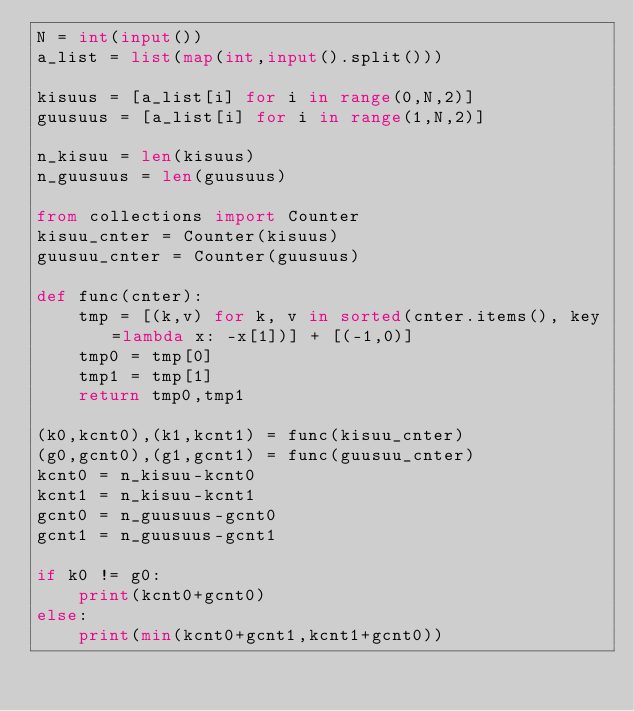Convert code to text. <code><loc_0><loc_0><loc_500><loc_500><_Python_>N = int(input())
a_list = list(map(int,input().split()))

kisuus = [a_list[i] for i in range(0,N,2)]
guusuus = [a_list[i] for i in range(1,N,2)]

n_kisuu = len(kisuus)
n_guusuus = len(guusuus)

from collections import Counter
kisuu_cnter = Counter(kisuus)
guusuu_cnter = Counter(guusuus)

def func(cnter):
    tmp = [(k,v) for k, v in sorted(cnter.items(), key=lambda x: -x[1])] + [(-1,0)]
    tmp0 = tmp[0]
    tmp1 = tmp[1]
    return tmp0,tmp1

(k0,kcnt0),(k1,kcnt1) = func(kisuu_cnter)
(g0,gcnt0),(g1,gcnt1) = func(guusuu_cnter)
kcnt0 = n_kisuu-kcnt0
kcnt1 = n_kisuu-kcnt1
gcnt0 = n_guusuus-gcnt0
gcnt1 = n_guusuus-gcnt1

if k0 != g0:
    print(kcnt0+gcnt0)
else:
    print(min(kcnt0+gcnt1,kcnt1+gcnt0))</code> 